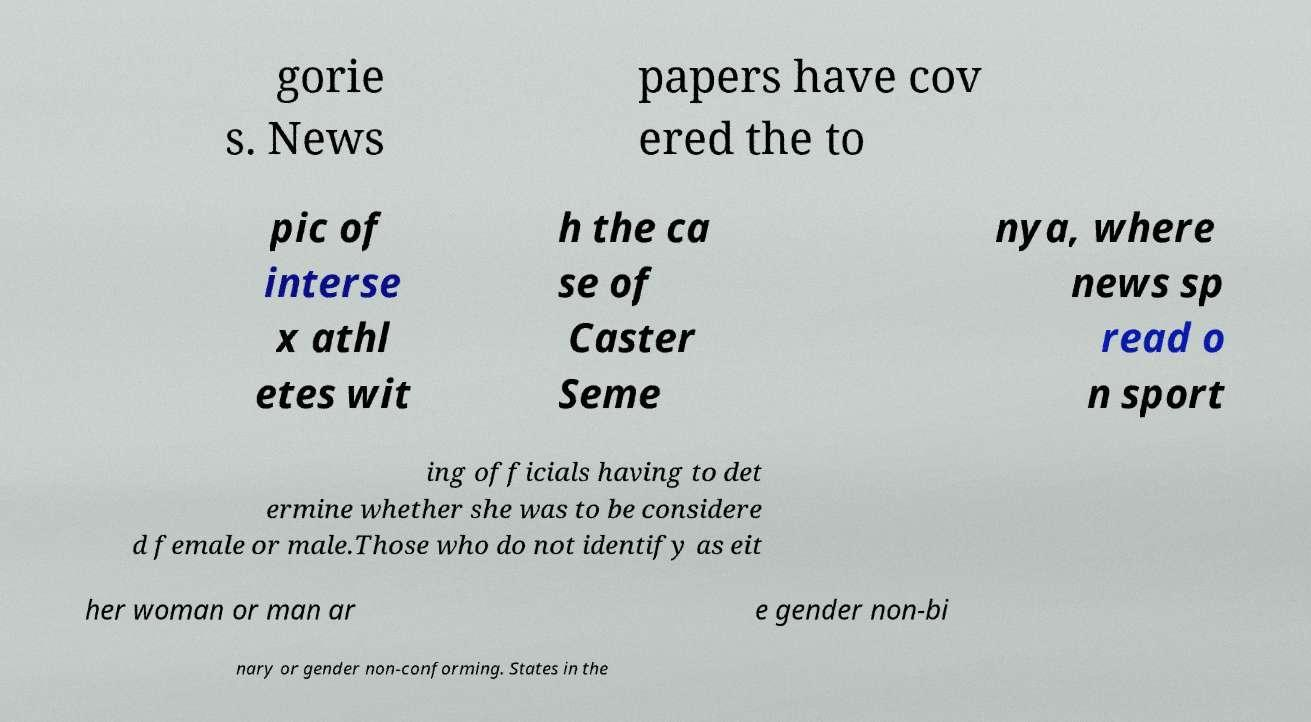Can you read and provide the text displayed in the image?This photo seems to have some interesting text. Can you extract and type it out for me? gorie s. News papers have cov ered the to pic of interse x athl etes wit h the ca se of Caster Seme nya, where news sp read o n sport ing officials having to det ermine whether she was to be considere d female or male.Those who do not identify as eit her woman or man ar e gender non-bi nary or gender non-conforming. States in the 